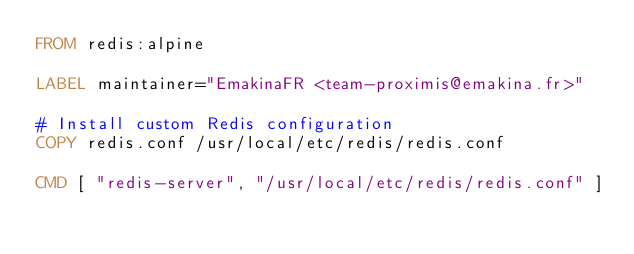Convert code to text. <code><loc_0><loc_0><loc_500><loc_500><_Dockerfile_>FROM redis:alpine

LABEL maintainer="EmakinaFR <team-proximis@emakina.fr>"

# Install custom Redis configuration
COPY redis.conf /usr/local/etc/redis/redis.conf

CMD [ "redis-server", "/usr/local/etc/redis/redis.conf" ]
</code> 